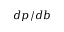Convert formula to latex. <formula><loc_0><loc_0><loc_500><loc_500>d p / d b</formula> 